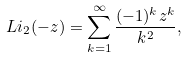Convert formula to latex. <formula><loc_0><loc_0><loc_500><loc_500>L i _ { 2 } ( - z ) = \sum _ { k = 1 } ^ { \infty } \frac { ( - 1 ) ^ { k } z ^ { k } } { k ^ { 2 } } ,</formula> 